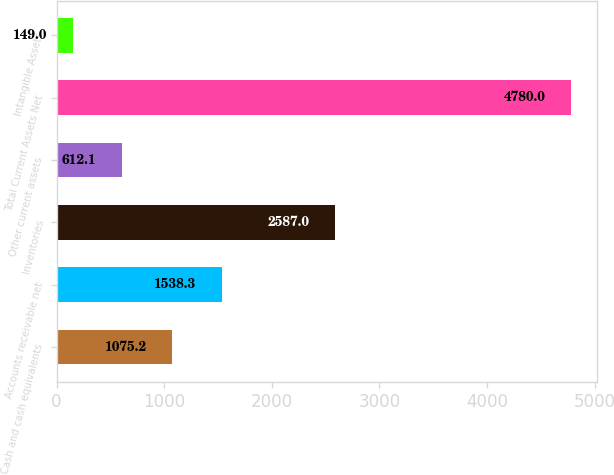Convert chart. <chart><loc_0><loc_0><loc_500><loc_500><bar_chart><fcel>Cash and cash equivalents<fcel>Accounts receivable net<fcel>Inventories<fcel>Other current assets<fcel>Total Current Assets Net<fcel>Intangible Assets<nl><fcel>1075.2<fcel>1538.3<fcel>2587<fcel>612.1<fcel>4780<fcel>149<nl></chart> 